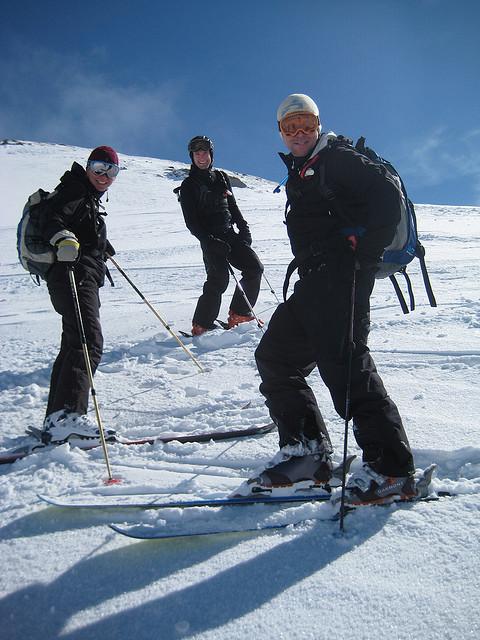What sport are these people participating in?
Write a very short answer. Skiing. What is covering the ground?
Be succinct. Snow. What emotion are the people expressing?
Quick response, please. Happiness. 